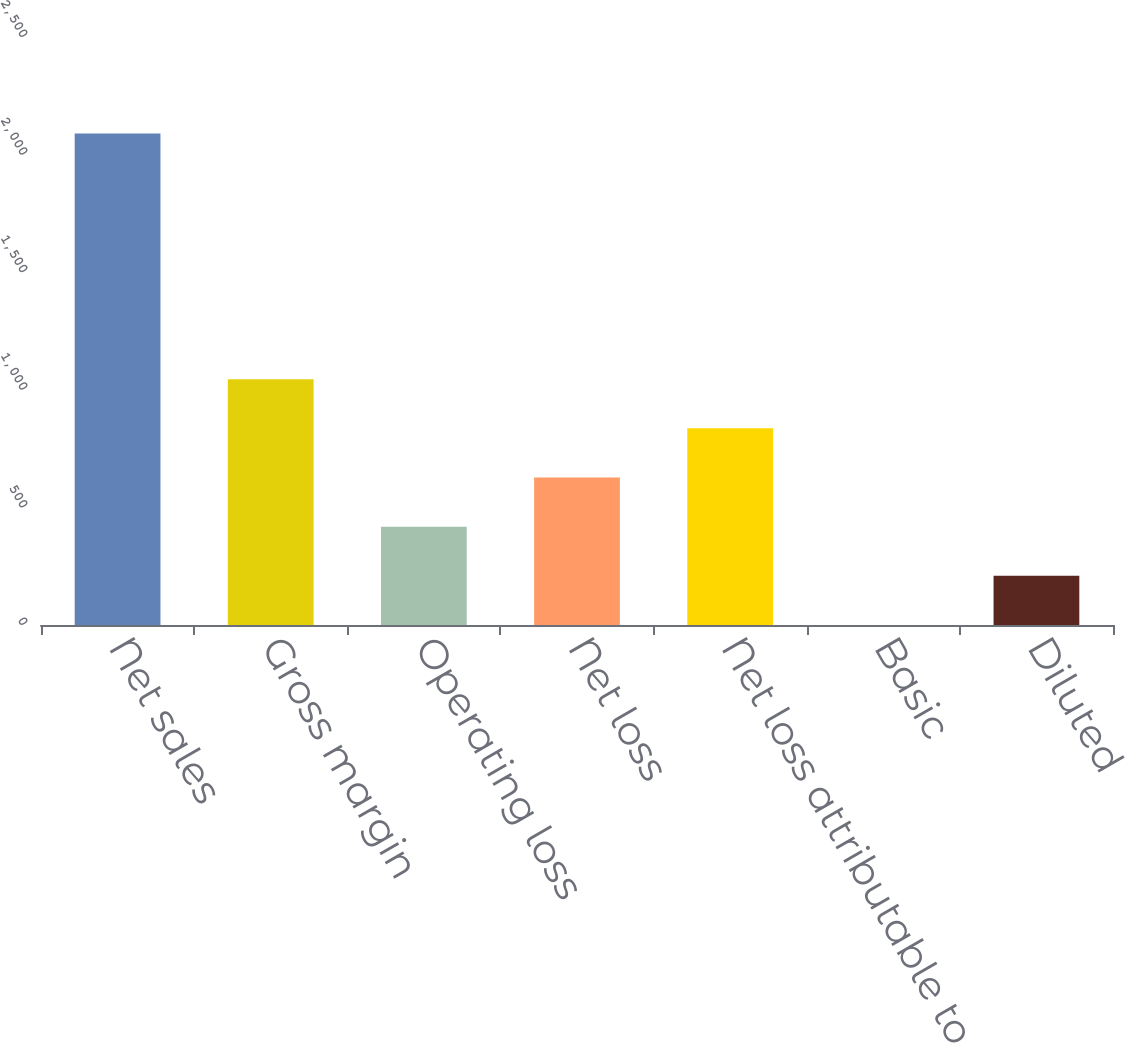<chart> <loc_0><loc_0><loc_500><loc_500><bar_chart><fcel>Net sales<fcel>Gross margin<fcel>Operating loss<fcel>Net loss<fcel>Net loss attributable to<fcel>Basic<fcel>Diluted<nl><fcel>2090<fcel>1045.09<fcel>418.15<fcel>627.13<fcel>836.11<fcel>0.19<fcel>209.17<nl></chart> 